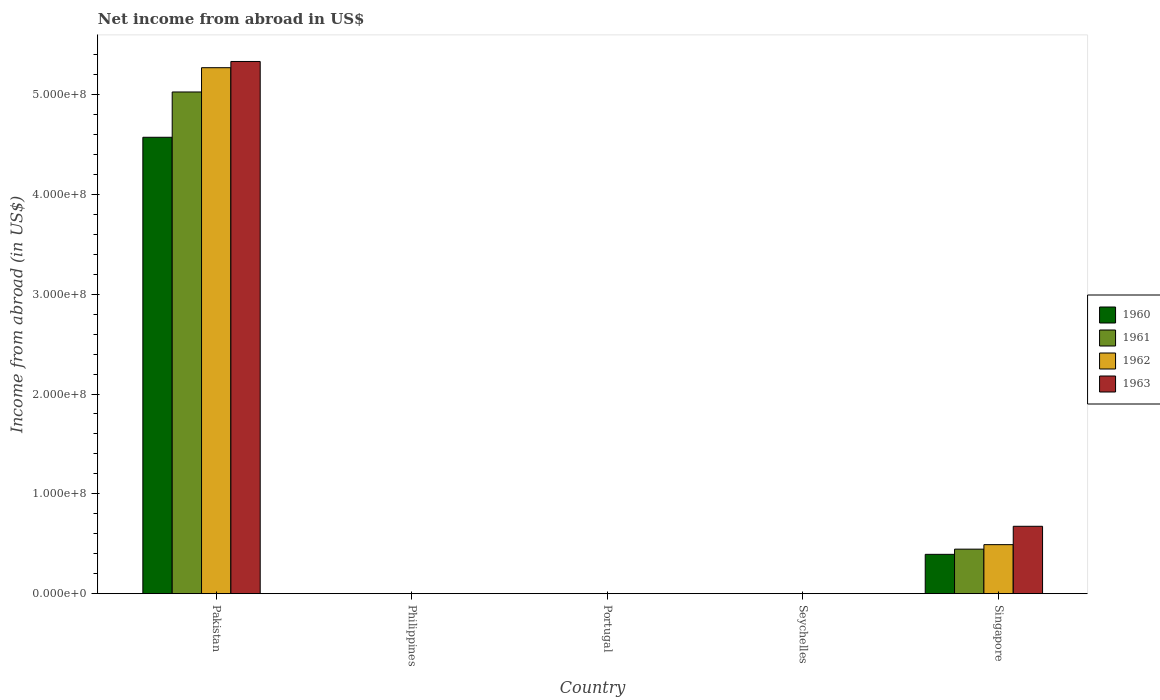How many different coloured bars are there?
Your answer should be compact. 4. Are the number of bars on each tick of the X-axis equal?
Make the answer very short. No. How many bars are there on the 2nd tick from the left?
Provide a short and direct response. 0. How many bars are there on the 4th tick from the right?
Your answer should be compact. 0. What is the net income from abroad in 1962 in Philippines?
Your response must be concise. 0. Across all countries, what is the maximum net income from abroad in 1963?
Provide a short and direct response. 5.33e+08. In which country was the net income from abroad in 1960 maximum?
Provide a succinct answer. Pakistan. What is the total net income from abroad in 1961 in the graph?
Your response must be concise. 5.47e+08. What is the difference between the net income from abroad in 1962 in Portugal and the net income from abroad in 1960 in Pakistan?
Provide a short and direct response. -4.57e+08. What is the average net income from abroad in 1961 per country?
Make the answer very short. 1.09e+08. What is the difference between the net income from abroad of/in 1961 and net income from abroad of/in 1962 in Singapore?
Provide a short and direct response. -4.50e+06. In how many countries, is the net income from abroad in 1961 greater than 140000000 US$?
Provide a succinct answer. 1. What is the ratio of the net income from abroad in 1960 in Pakistan to that in Singapore?
Your answer should be compact. 11.61. Is the difference between the net income from abroad in 1961 in Pakistan and Singapore greater than the difference between the net income from abroad in 1962 in Pakistan and Singapore?
Ensure brevity in your answer.  No. What is the difference between the highest and the lowest net income from abroad in 1962?
Provide a succinct answer. 5.27e+08. Is it the case that in every country, the sum of the net income from abroad in 1960 and net income from abroad in 1962 is greater than the sum of net income from abroad in 1963 and net income from abroad in 1961?
Offer a very short reply. No. How many countries are there in the graph?
Give a very brief answer. 5. Does the graph contain grids?
Your answer should be compact. No. How are the legend labels stacked?
Provide a short and direct response. Vertical. What is the title of the graph?
Give a very brief answer. Net income from abroad in US$. Does "2001" appear as one of the legend labels in the graph?
Make the answer very short. No. What is the label or title of the X-axis?
Your answer should be compact. Country. What is the label or title of the Y-axis?
Make the answer very short. Income from abroad (in US$). What is the Income from abroad (in US$) in 1960 in Pakistan?
Give a very brief answer. 4.57e+08. What is the Income from abroad (in US$) of 1961 in Pakistan?
Provide a short and direct response. 5.03e+08. What is the Income from abroad (in US$) in 1962 in Pakistan?
Keep it short and to the point. 5.27e+08. What is the Income from abroad (in US$) in 1963 in Pakistan?
Your answer should be compact. 5.33e+08. What is the Income from abroad (in US$) of 1960 in Philippines?
Offer a terse response. 0. What is the Income from abroad (in US$) of 1963 in Philippines?
Make the answer very short. 0. What is the Income from abroad (in US$) in 1961 in Portugal?
Ensure brevity in your answer.  0. What is the Income from abroad (in US$) of 1962 in Portugal?
Ensure brevity in your answer.  0. What is the Income from abroad (in US$) of 1963 in Portugal?
Offer a terse response. 0. What is the Income from abroad (in US$) of 1961 in Seychelles?
Offer a very short reply. 0. What is the Income from abroad (in US$) of 1960 in Singapore?
Your response must be concise. 3.94e+07. What is the Income from abroad (in US$) of 1961 in Singapore?
Provide a short and direct response. 4.46e+07. What is the Income from abroad (in US$) in 1962 in Singapore?
Your answer should be compact. 4.91e+07. What is the Income from abroad (in US$) in 1963 in Singapore?
Offer a terse response. 6.75e+07. Across all countries, what is the maximum Income from abroad (in US$) in 1960?
Your answer should be very brief. 4.57e+08. Across all countries, what is the maximum Income from abroad (in US$) in 1961?
Keep it short and to the point. 5.03e+08. Across all countries, what is the maximum Income from abroad (in US$) in 1962?
Offer a terse response. 5.27e+08. Across all countries, what is the maximum Income from abroad (in US$) of 1963?
Keep it short and to the point. 5.33e+08. Across all countries, what is the minimum Income from abroad (in US$) in 1962?
Your answer should be very brief. 0. What is the total Income from abroad (in US$) of 1960 in the graph?
Offer a very short reply. 4.97e+08. What is the total Income from abroad (in US$) of 1961 in the graph?
Offer a terse response. 5.47e+08. What is the total Income from abroad (in US$) in 1962 in the graph?
Offer a very short reply. 5.76e+08. What is the total Income from abroad (in US$) of 1963 in the graph?
Give a very brief answer. 6.01e+08. What is the difference between the Income from abroad (in US$) in 1960 in Pakistan and that in Singapore?
Provide a succinct answer. 4.18e+08. What is the difference between the Income from abroad (in US$) in 1961 in Pakistan and that in Singapore?
Provide a short and direct response. 4.58e+08. What is the difference between the Income from abroad (in US$) of 1962 in Pakistan and that in Singapore?
Give a very brief answer. 4.78e+08. What is the difference between the Income from abroad (in US$) in 1963 in Pakistan and that in Singapore?
Your answer should be compact. 4.66e+08. What is the difference between the Income from abroad (in US$) of 1960 in Pakistan and the Income from abroad (in US$) of 1961 in Singapore?
Your response must be concise. 4.13e+08. What is the difference between the Income from abroad (in US$) of 1960 in Pakistan and the Income from abroad (in US$) of 1962 in Singapore?
Offer a very short reply. 4.08e+08. What is the difference between the Income from abroad (in US$) of 1960 in Pakistan and the Income from abroad (in US$) of 1963 in Singapore?
Ensure brevity in your answer.  3.90e+08. What is the difference between the Income from abroad (in US$) of 1961 in Pakistan and the Income from abroad (in US$) of 1962 in Singapore?
Provide a short and direct response. 4.54e+08. What is the difference between the Income from abroad (in US$) of 1961 in Pakistan and the Income from abroad (in US$) of 1963 in Singapore?
Your answer should be very brief. 4.35e+08. What is the difference between the Income from abroad (in US$) in 1962 in Pakistan and the Income from abroad (in US$) in 1963 in Singapore?
Provide a succinct answer. 4.59e+08. What is the average Income from abroad (in US$) in 1960 per country?
Give a very brief answer. 9.93e+07. What is the average Income from abroad (in US$) of 1961 per country?
Offer a very short reply. 1.09e+08. What is the average Income from abroad (in US$) in 1962 per country?
Provide a succinct answer. 1.15e+08. What is the average Income from abroad (in US$) in 1963 per country?
Make the answer very short. 1.20e+08. What is the difference between the Income from abroad (in US$) of 1960 and Income from abroad (in US$) of 1961 in Pakistan?
Give a very brief answer. -4.54e+07. What is the difference between the Income from abroad (in US$) of 1960 and Income from abroad (in US$) of 1962 in Pakistan?
Provide a short and direct response. -6.97e+07. What is the difference between the Income from abroad (in US$) of 1960 and Income from abroad (in US$) of 1963 in Pakistan?
Your response must be concise. -7.59e+07. What is the difference between the Income from abroad (in US$) in 1961 and Income from abroad (in US$) in 1962 in Pakistan?
Ensure brevity in your answer.  -2.43e+07. What is the difference between the Income from abroad (in US$) of 1961 and Income from abroad (in US$) of 1963 in Pakistan?
Provide a short and direct response. -3.06e+07. What is the difference between the Income from abroad (in US$) in 1962 and Income from abroad (in US$) in 1963 in Pakistan?
Offer a terse response. -6.23e+06. What is the difference between the Income from abroad (in US$) in 1960 and Income from abroad (in US$) in 1961 in Singapore?
Offer a terse response. -5.20e+06. What is the difference between the Income from abroad (in US$) of 1960 and Income from abroad (in US$) of 1962 in Singapore?
Provide a short and direct response. -9.70e+06. What is the difference between the Income from abroad (in US$) of 1960 and Income from abroad (in US$) of 1963 in Singapore?
Offer a terse response. -2.81e+07. What is the difference between the Income from abroad (in US$) in 1961 and Income from abroad (in US$) in 1962 in Singapore?
Make the answer very short. -4.50e+06. What is the difference between the Income from abroad (in US$) in 1961 and Income from abroad (in US$) in 1963 in Singapore?
Your response must be concise. -2.29e+07. What is the difference between the Income from abroad (in US$) in 1962 and Income from abroad (in US$) in 1963 in Singapore?
Provide a succinct answer. -1.84e+07. What is the ratio of the Income from abroad (in US$) of 1960 in Pakistan to that in Singapore?
Keep it short and to the point. 11.61. What is the ratio of the Income from abroad (in US$) in 1961 in Pakistan to that in Singapore?
Keep it short and to the point. 11.27. What is the ratio of the Income from abroad (in US$) in 1962 in Pakistan to that in Singapore?
Keep it short and to the point. 10.73. What is the ratio of the Income from abroad (in US$) of 1963 in Pakistan to that in Singapore?
Your answer should be very brief. 7.9. What is the difference between the highest and the lowest Income from abroad (in US$) in 1960?
Your response must be concise. 4.57e+08. What is the difference between the highest and the lowest Income from abroad (in US$) in 1961?
Your response must be concise. 5.03e+08. What is the difference between the highest and the lowest Income from abroad (in US$) of 1962?
Your answer should be compact. 5.27e+08. What is the difference between the highest and the lowest Income from abroad (in US$) of 1963?
Give a very brief answer. 5.33e+08. 